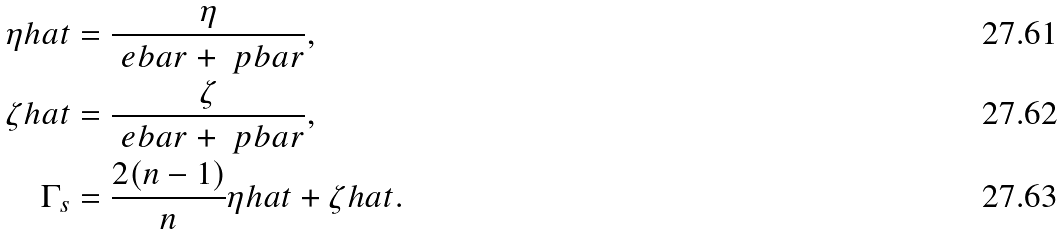<formula> <loc_0><loc_0><loc_500><loc_500>\eta h a t & = \frac { \eta } { \ e b a r + \ p b a r } , \\ \zeta h a t & = \frac { \zeta } { \ e b a r + \ p b a r } , \\ \Gamma _ { s } & = \frac { 2 ( n - 1 ) } { n } \eta h a t + \zeta h a t .</formula> 